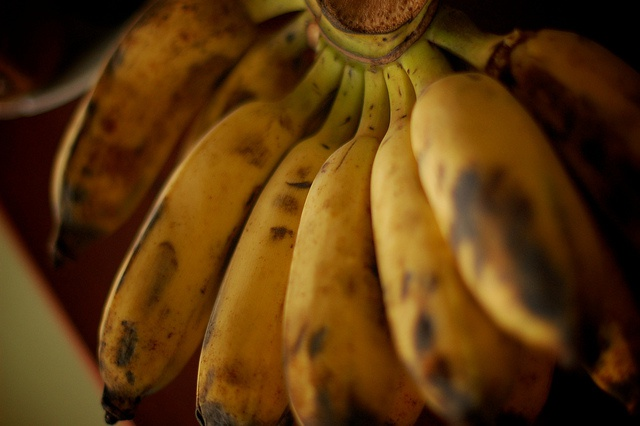Describe the objects in this image and their specific colors. I can see banana in maroon, black, and olive tones and dining table in black, maroon, and olive tones in this image. 